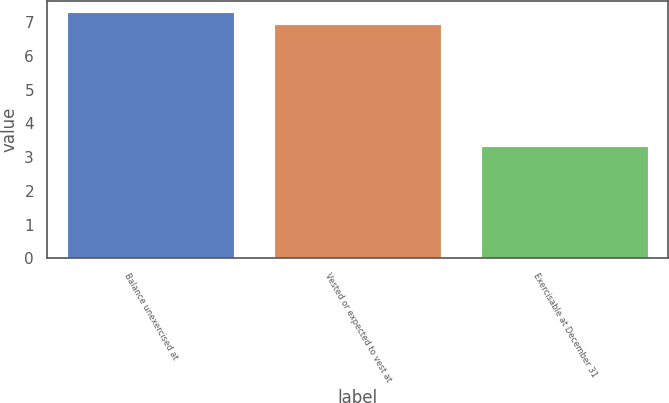Convert chart. <chart><loc_0><loc_0><loc_500><loc_500><bar_chart><fcel>Balance unexercised at<fcel>Vested or expected to vest at<fcel>Exercisable at December 31<nl><fcel>7.27<fcel>6.9<fcel>3.3<nl></chart> 